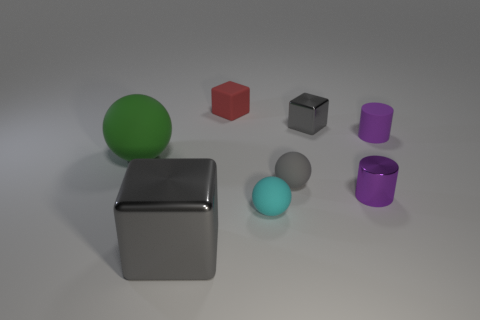Subtract all big yellow cubes. Subtract all rubber cylinders. How many objects are left? 7 Add 5 small gray spheres. How many small gray spheres are left? 6 Add 5 purple metallic objects. How many purple metallic objects exist? 6 Add 2 big blue matte balls. How many objects exist? 10 Subtract all green spheres. How many spheres are left? 2 Subtract all tiny gray matte balls. How many balls are left? 2 Subtract 0 red balls. How many objects are left? 8 Subtract all cylinders. How many objects are left? 6 Subtract 1 blocks. How many blocks are left? 2 Subtract all cyan balls. Subtract all yellow cylinders. How many balls are left? 2 